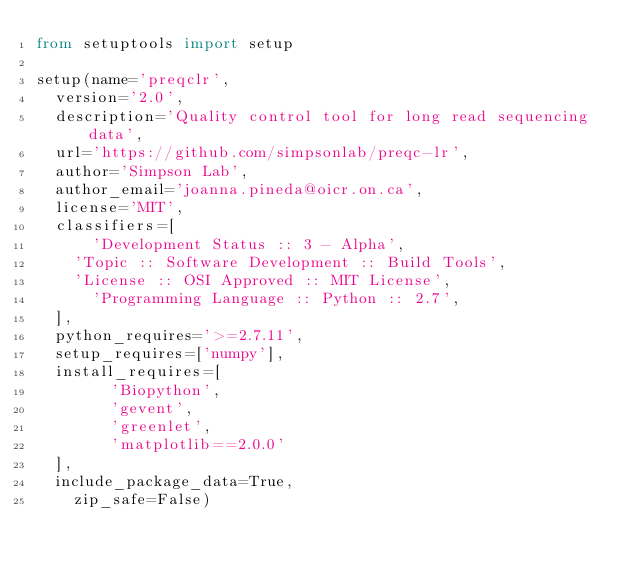<code> <loc_0><loc_0><loc_500><loc_500><_Python_>from setuptools import setup

setup(name='preqclr',
	version='2.0',
	description='Quality control tool for long read sequencing data',
	url='https://github.com/simpsonlab/preqc-lr',
	author='Simpson Lab',
	author_email='joanna.pineda@oicr.on.ca',
	license='MIT',
	classifiers=[
    	'Development Status :: 3 - Alpha',
		'Topic :: Software Development :: Build Tools',
		'License :: OSI Approved :: MIT License',
    	'Programming Language :: Python :: 2.7',
	],
	python_requires='>=2.7.11',
	setup_requires=['numpy'],
	install_requires=[
        'Biopython',
        'gevent',
        'greenlet',
        'matplotlib==2.0.0'
	],
	include_package_data=True,
    zip_safe=False)
</code> 